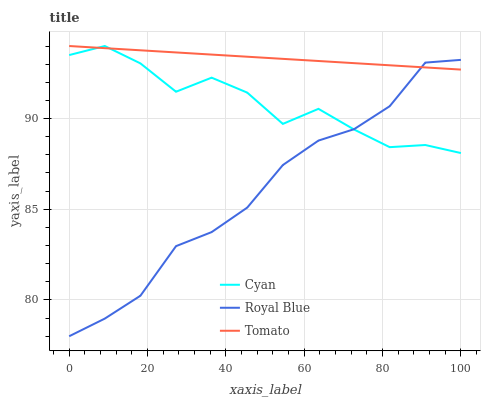Does Cyan have the minimum area under the curve?
Answer yes or no. No. Does Cyan have the maximum area under the curve?
Answer yes or no. No. Is Royal Blue the smoothest?
Answer yes or no. No. Is Royal Blue the roughest?
Answer yes or no. No. Does Cyan have the lowest value?
Answer yes or no. No. Does Royal Blue have the highest value?
Answer yes or no. No. 